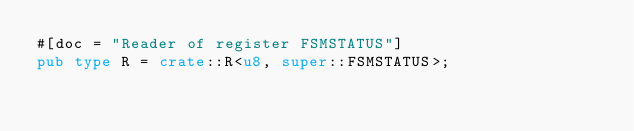Convert code to text. <code><loc_0><loc_0><loc_500><loc_500><_Rust_>#[doc = "Reader of register FSMSTATUS"]
pub type R = crate::R<u8, super::FSMSTATUS>;</code> 